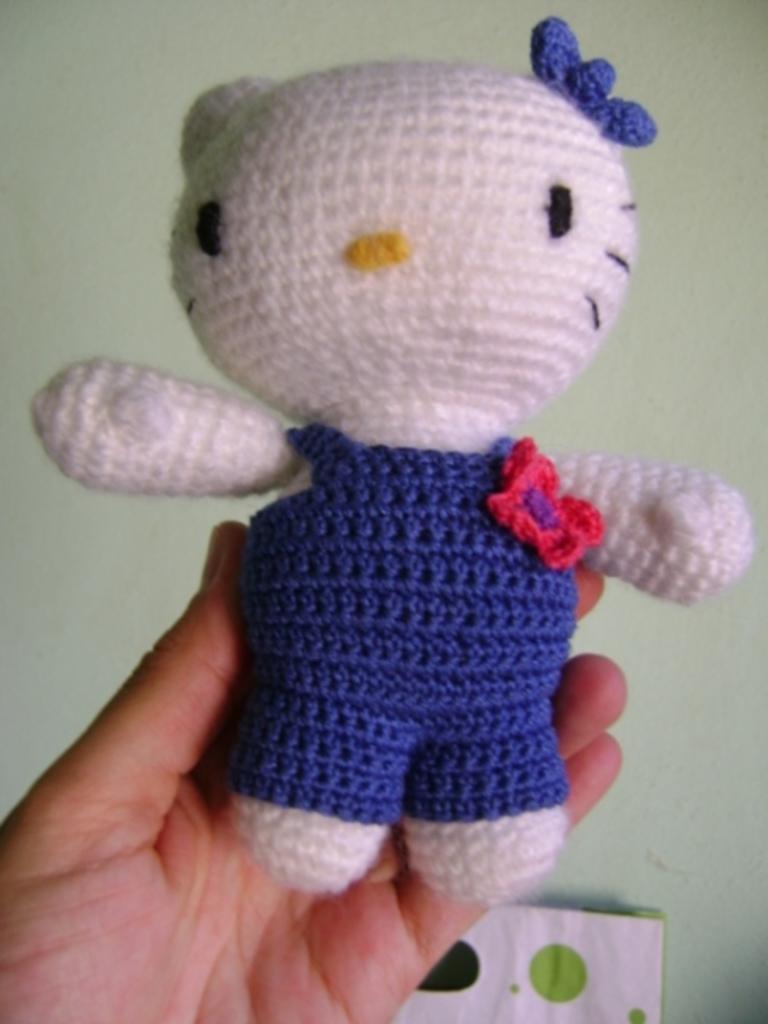In one or two sentences, can you explain what this image depicts? In the image in the center, we can see one human hand holding toy, which is in blue and white color. In the background there is a wall and paper. 